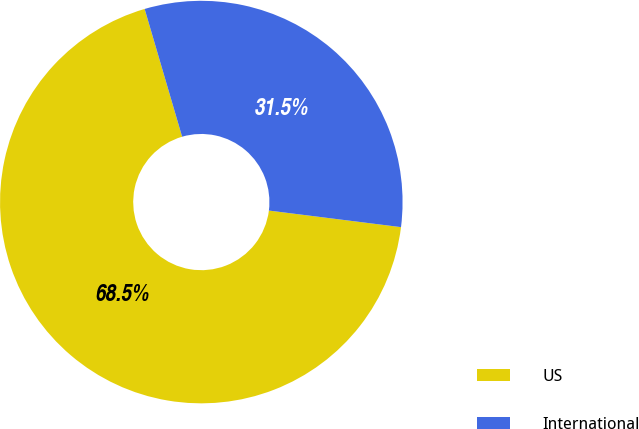<chart> <loc_0><loc_0><loc_500><loc_500><pie_chart><fcel>US<fcel>International<nl><fcel>68.47%<fcel>31.53%<nl></chart> 